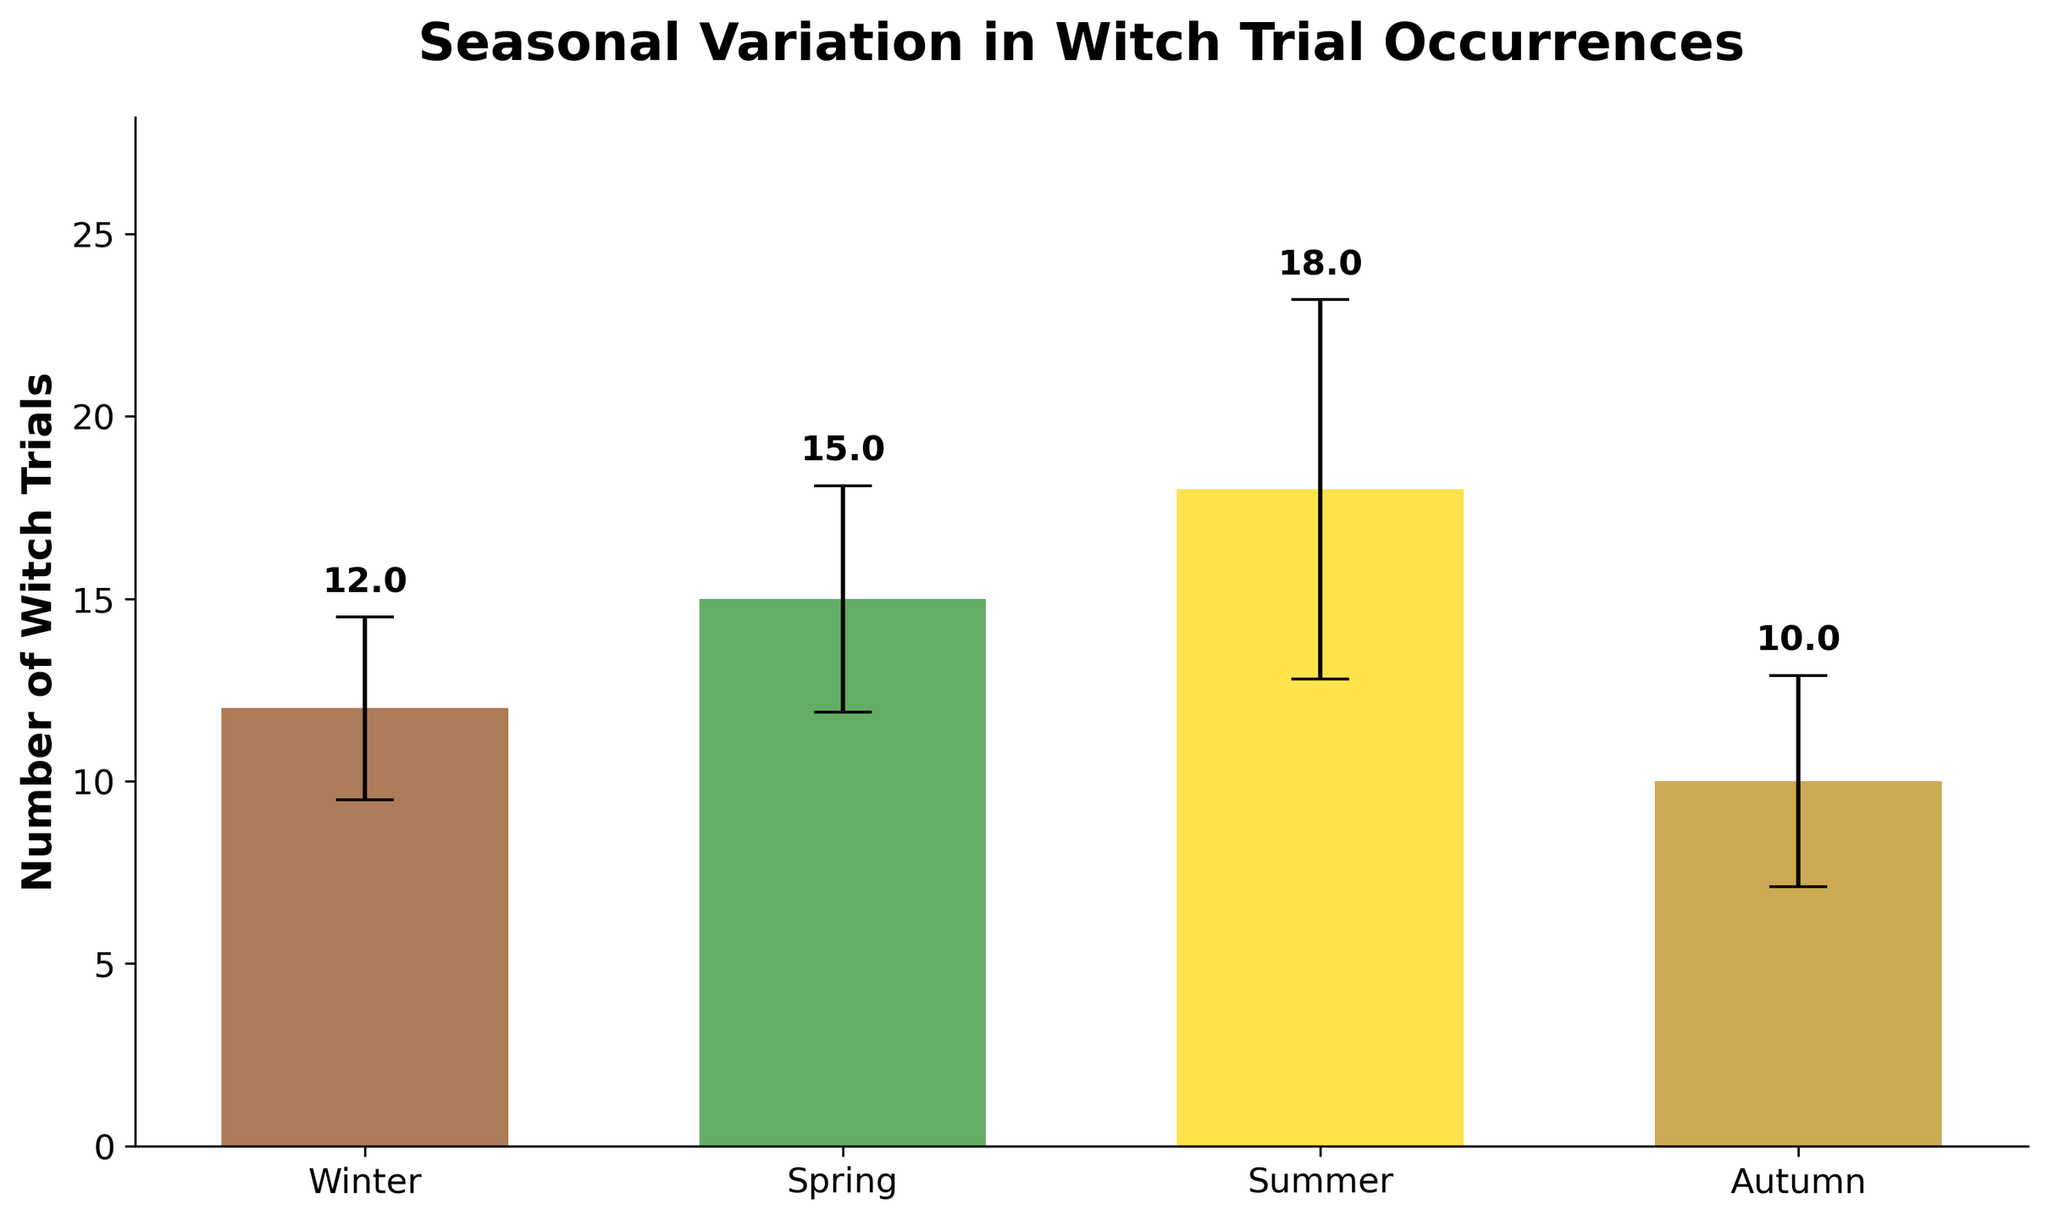What is the title of the figure? The title of the figure is displayed at the top as "Seasonal Variation in Witch Trial Occurrences". Observing the topmost part of the plot indicates the title clearly.
Answer: Seasonal Variation in Witch Trial Occurrences Which season has the highest mean number of witch trials? The bars representing each season show their respective mean number of witch trials. The tallest bar indicates the highest value. In this figure, the bar for Summer is the highest.
Answer: Summer How many seasons are represented in the figure? The x-axis lists the different seasons and each bar represents one season. Counting these, Winter, Spring, Summer, and Autumn, shows there are four seasons.
Answer: 4 What does the y-axis represent? Observing the label on the y-axis, it shows "Number of Witch Trials". This indicates that the y-axis measures the number of witch trials.
Answer: Number of Witch Trials Which season has the least reliable historical data based on the error bars? The error bars visually indicate the standard deviation, with larger bars representing more fluctuation. The largest error bar is for Summer, indicating the least reliable data.
Answer: Summer What is the mean number of witch trials in Winter and how reliable is this data? The bar above Winter shows the mean number of witch trials, with an associated error bar representing reliability. For Winter, the mean is 12, and the error bar (standard deviation) is 2.5.
Answer: 12, Std. Dev: 2.5 Compare the mean number of witch trials between Spring and Autumn. Which one is higher, and by how much? The mean values of witch trials for Spring and Autumn can be compared by observing the height of bars. Spring has a mean of 15, and Autumn has 10. The difference is 15 - 10 = 5.
Answer: Spring, by 5 Calculate the combined mean number of witch trials for Winter and Spring. Adding the mean number of witch trials for Winter (12) and Spring (15) results in 12 + 15 = 27.
Answer: 27 What is the range of values depicted on the y-axis? The range of the y-axis starts from 0 (the bottom) up to a bit above the maximum value of the bars plus their error bars. The y-axis extends to slightly more than 23.
Answer: 0 to approximately 23 Explain why it's important to include error bars in this figure. Error bars show the reliability of the data by indicating variability or standard deviation. Without them, one might assume the data points are precise. For historical data, which often has varying degrees of accuracy, error bars help convey the uncertainty.
Answer: They show data variability and reliability 